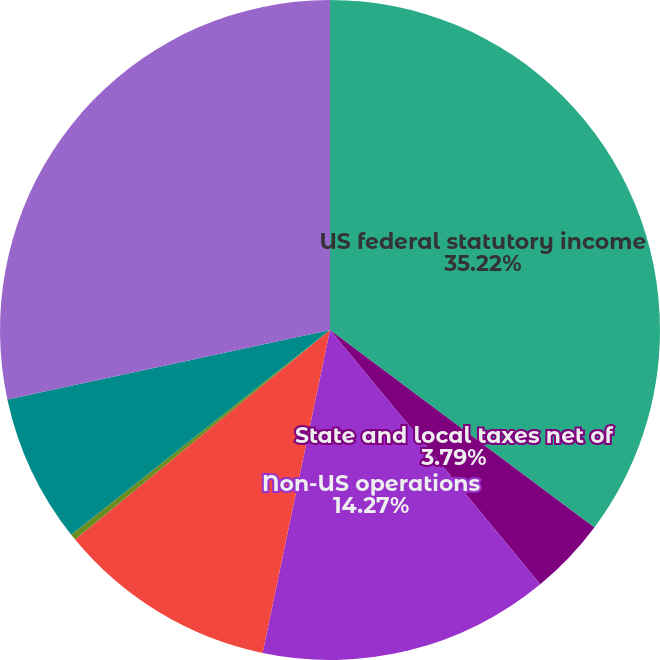Convert chart to OTSL. <chart><loc_0><loc_0><loc_500><loc_500><pie_chart><fcel>US federal statutory income<fcel>State and local taxes net of<fcel>Non-US operations<fcel>Tax credits<fcel>Tax-exempt income including<fcel>Non-deductible legal expenses<fcel>Effective income tax rate<nl><fcel>35.21%<fcel>3.79%<fcel>14.27%<fcel>10.77%<fcel>0.3%<fcel>7.28%<fcel>28.37%<nl></chart> 